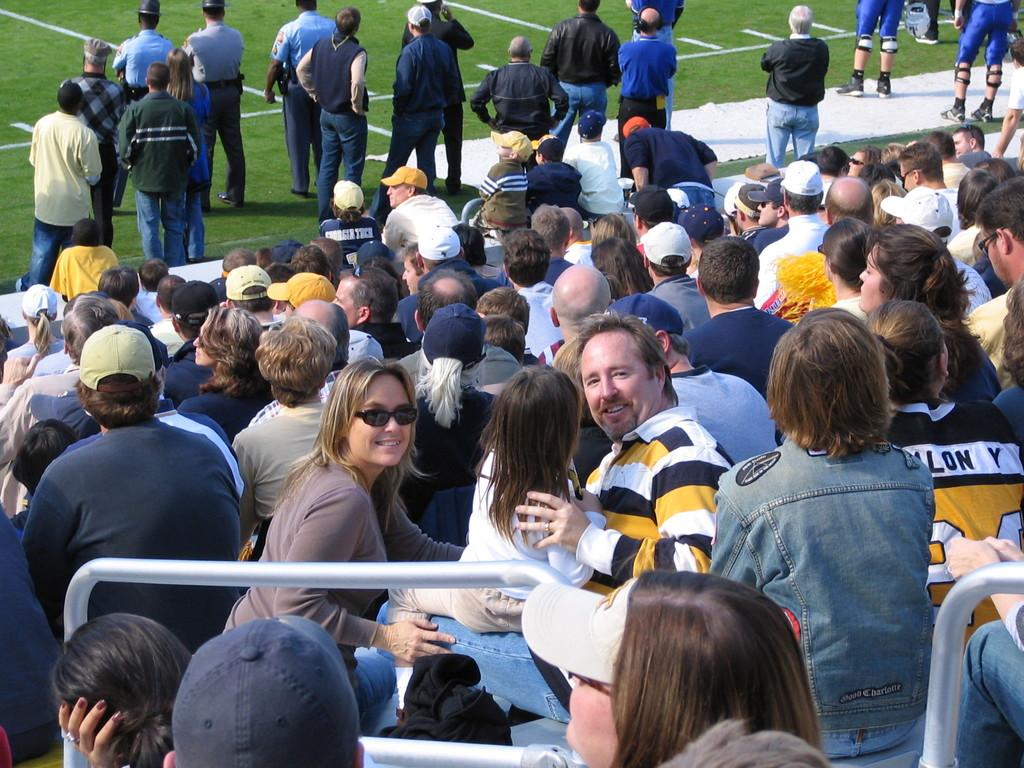What is the main setting of the image? The main setting of the image is a stadium. What are the people in the stadium doing? There is a group of people sitting in the stadium. What is the ground in the stadium like? There is a grassy ground in the image. Are there any people standing on the grassy ground? Yes, there are many people standing on the grassy ground. How many eggs are visible on the faces of the people standing on the grassy ground? There are no eggs visible on the faces of the people standing on the grassy ground, as eggs are not present in the image. 